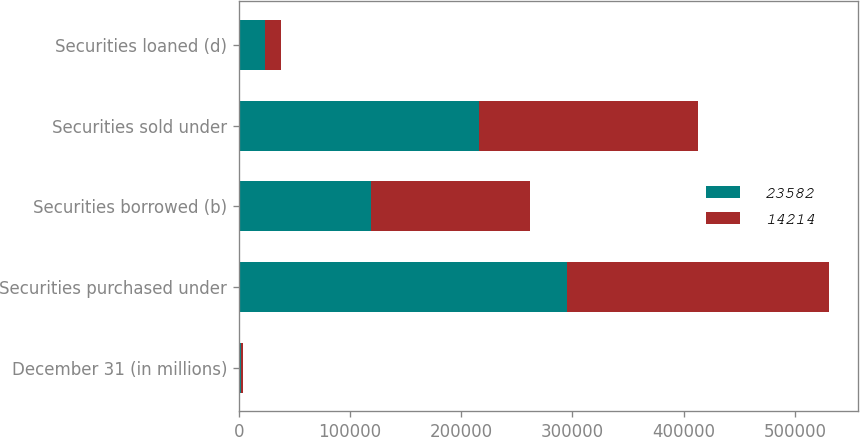Convert chart. <chart><loc_0><loc_0><loc_500><loc_500><stacked_bar_chart><ecel><fcel>December 31 (in millions)<fcel>Securities purchased under<fcel>Securities borrowed (b)<fcel>Securities sold under<fcel>Securities loaned (d)<nl><fcel>23582<fcel>2012<fcel>295413<fcel>119017<fcel>215560<fcel>23582<nl><fcel>14214<fcel>2011<fcel>235000<fcel>142462<fcel>197789<fcel>14214<nl></chart> 